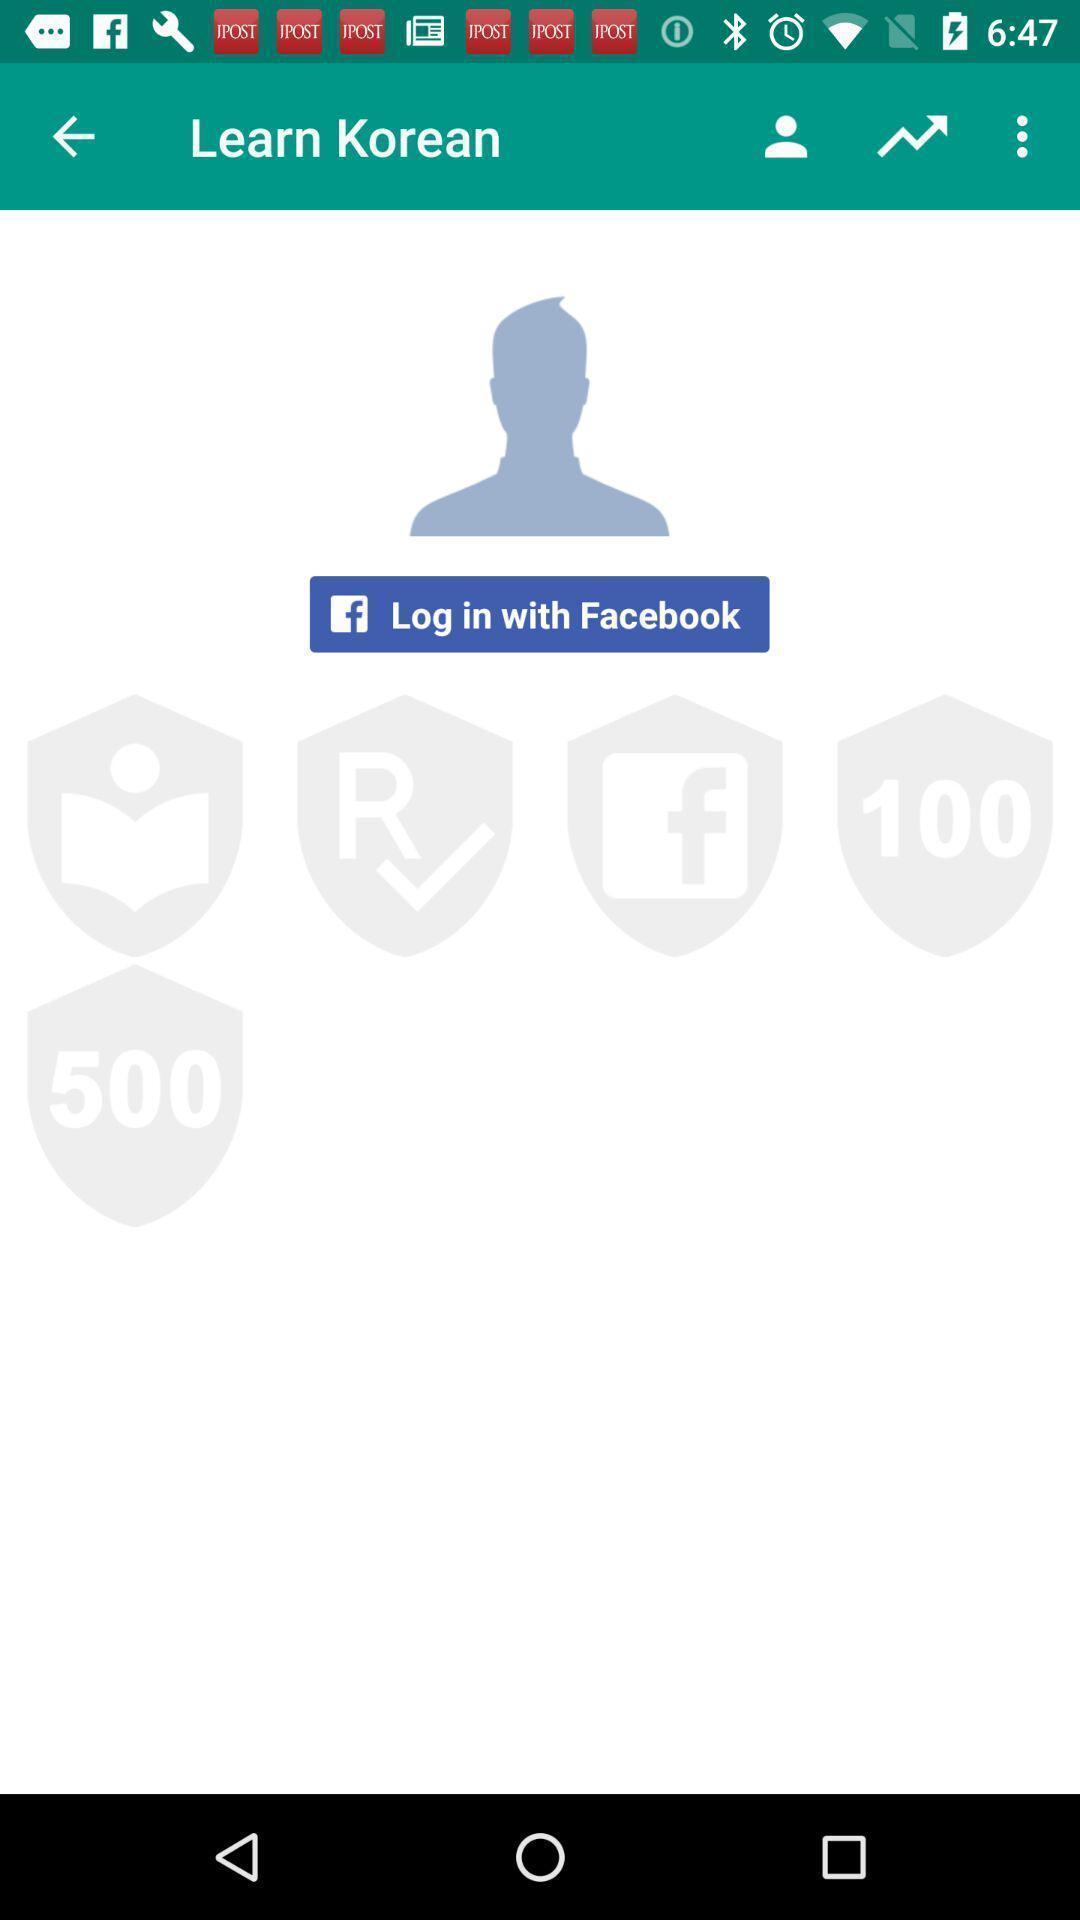Describe the visual elements of this screenshot. Page to learn korean language. 